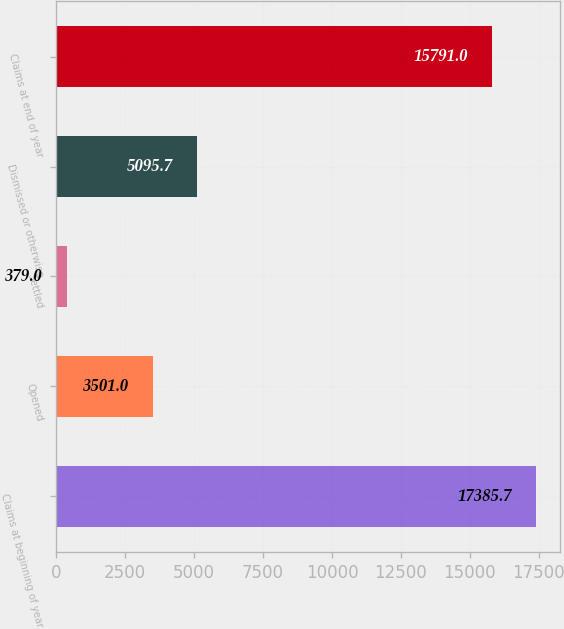Convert chart to OTSL. <chart><loc_0><loc_0><loc_500><loc_500><bar_chart><fcel>Claims at beginning of year<fcel>Opened<fcel>Settled<fcel>Dismissed or otherwise<fcel>Claims at end of year<nl><fcel>17385.7<fcel>3501<fcel>379<fcel>5095.7<fcel>15791<nl></chart> 